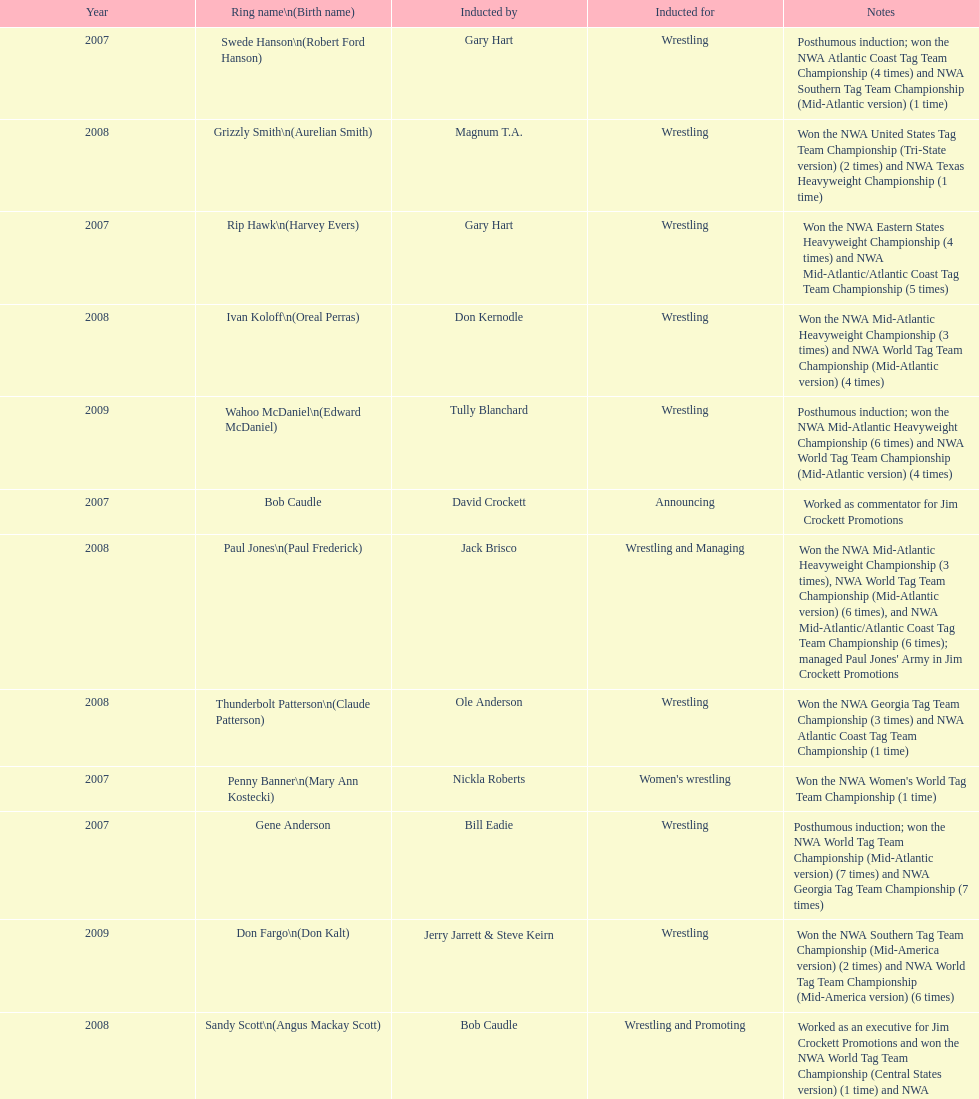How many members were inducted for announcing? 2. 